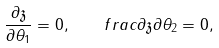<formula> <loc_0><loc_0><loc_500><loc_500>\frac { \partial \mathfrak { z } } { \partial \theta _ { 1 } } = 0 , \quad f r a c { \partial \mathfrak { z } } { \partial \theta _ { 2 } } = 0 ,</formula> 